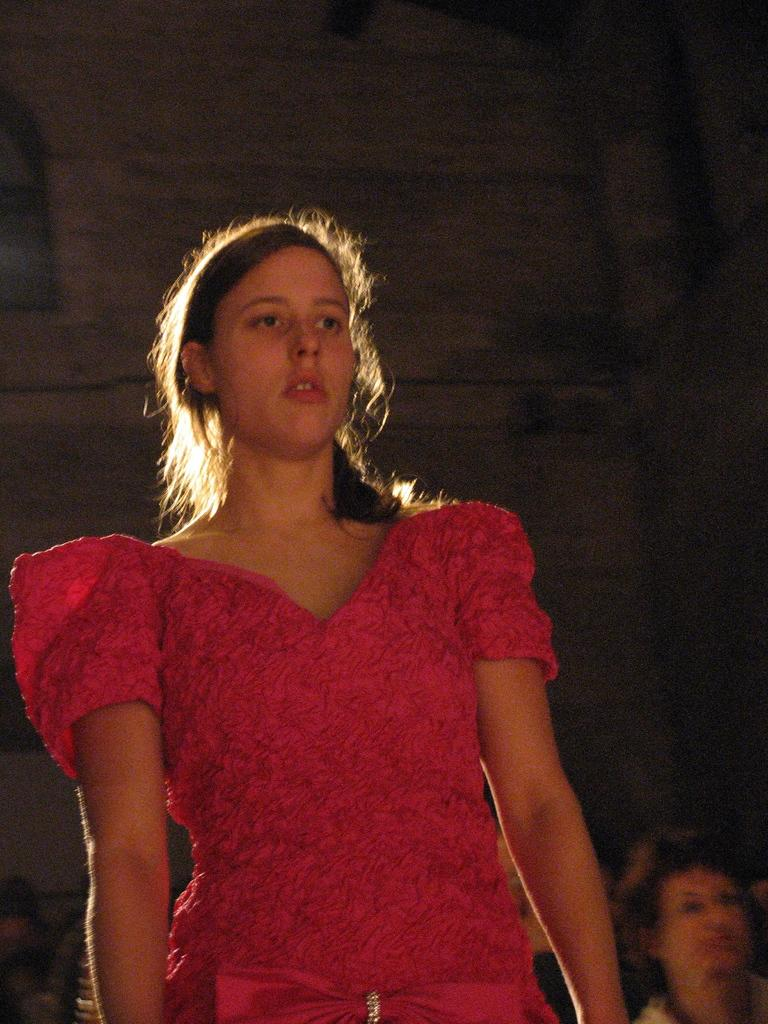What is the main subject of the image? There is a woman standing in the middle of the image. Are there any other people visible in the image? Yes, there are some persons at the bottom of the image. What can be seen in the background of the image? There is a wall in the background of the image. What type of vessel is being used by the woman in the image? There is no vessel present in the image; the woman is standing on the ground. 